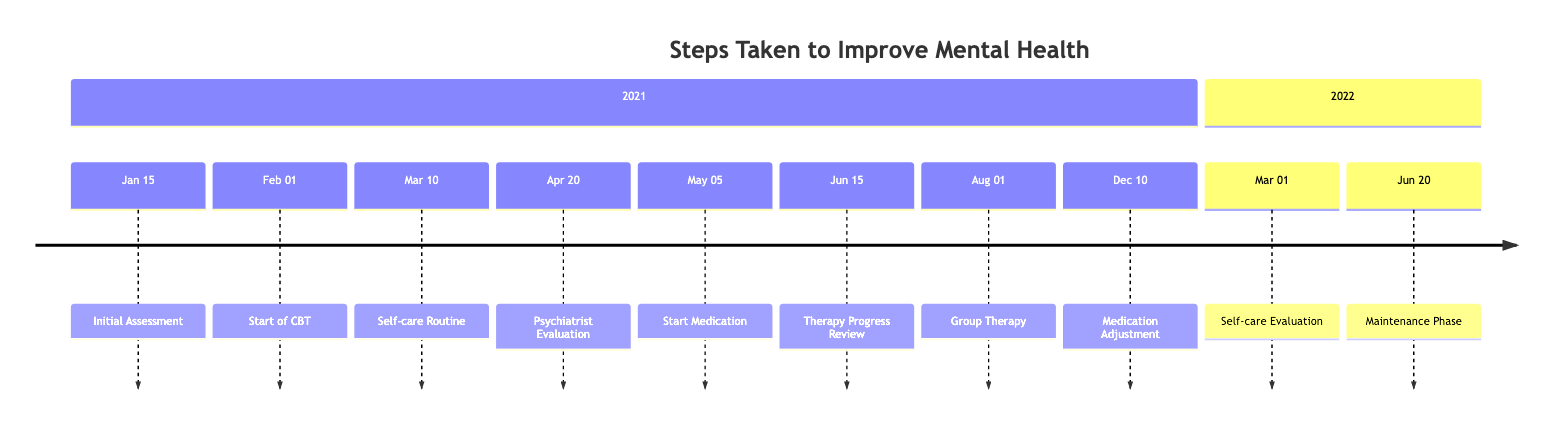What is the first milestone in the timeline? The first milestone listed in the timeline is "Initial Assessment" which is dated January 15, 2021.
Answer: Initial Assessment How many therapy-related milestones are included in the timeline? There are five therapy-related milestones in the timeline: "Initial Assessment," "Start of CBT," "Therapy Progress Review," "Integrated Group Therapy," and "Continuation and Maintenance."
Answer: 5 What date did the medication start? The medication began on May 5, 2021, as indicated by the milestone "Start of Medication."
Answer: May 5, 2021 What was the outcome of the "Therapy Progress Review" milestone? The "Therapy Progress Review" led to a recognition of improvements in managing stress and anxiety, resulting in an adjustment of the therapy approach.
Answer: Improvements noted When did the introduction of the self-care routine occur? The self-care routine was introduced on March 10, 2021, as part of the listed milestones in the timeline.
Answer: March 10, 2021 Which milestone indicates a change in medication dosage? The milestone "Medication Adjustment" on December 10, 2021, indicates that there was a follow-up with the psychiatrist and an adjustment in the medication dosage based on response and side effects.
Answer: Medication Adjustment What activities were incorporated into the self-care routine? The self-care routine included mindfulness meditation, journaling, and a regular exercise regimen according to the description of the milestone.
Answer: Mindfulness meditation, journaling, exercise How long after starting CBT was the therapy progress reviewed? The "Start of CBT" was on February 1, 2021, and the "Therapy Progress Review" took place on June 15, 2021. This sums up to approximately 4 and a half months later.
Answer: 4 and a half months What does the timeline suggest about the frequency of therapy sessions over time? Initially, therapy sessions began weekly, then reviewed and adjusted to bi-weekly sessions as part of the long-term maintenance plan.
Answer: Weekly, then bi-weekly 